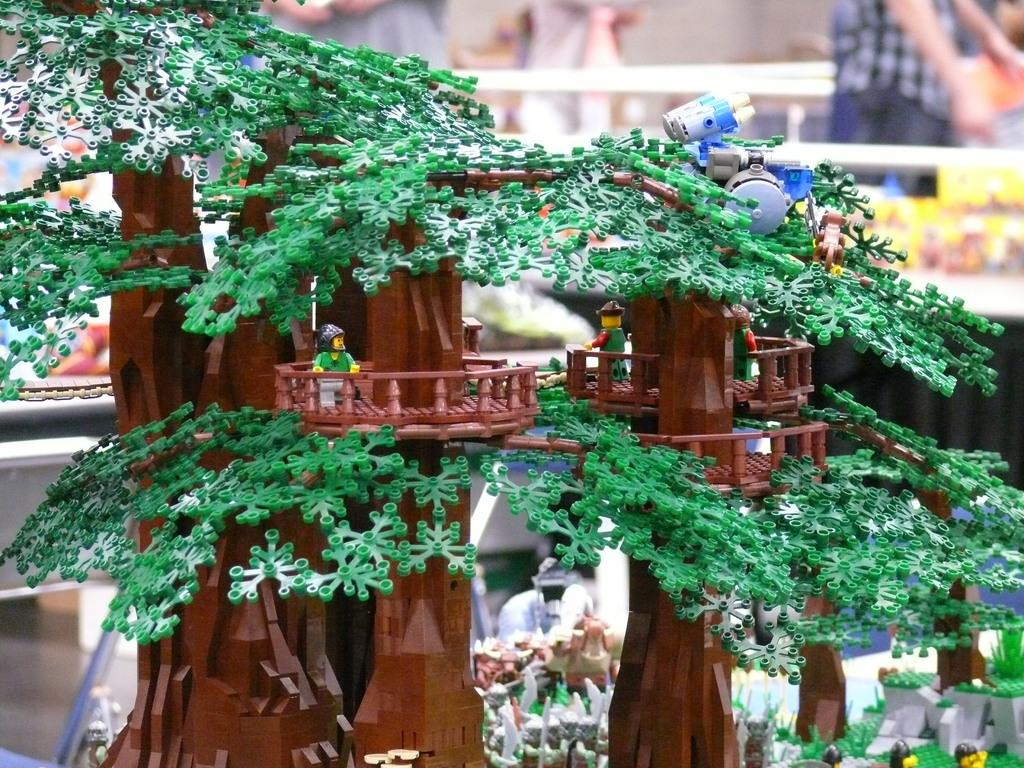What objects can be seen in the image? A: There are toys in the image. Can you describe the background of the image? The background of the image is blurred. Are there any people present in the image? Yes, there are people in the image. What type of screw can be seen holding the toys together in the image? There is no screw present in the image; the toys are not held together by any visible screws. 